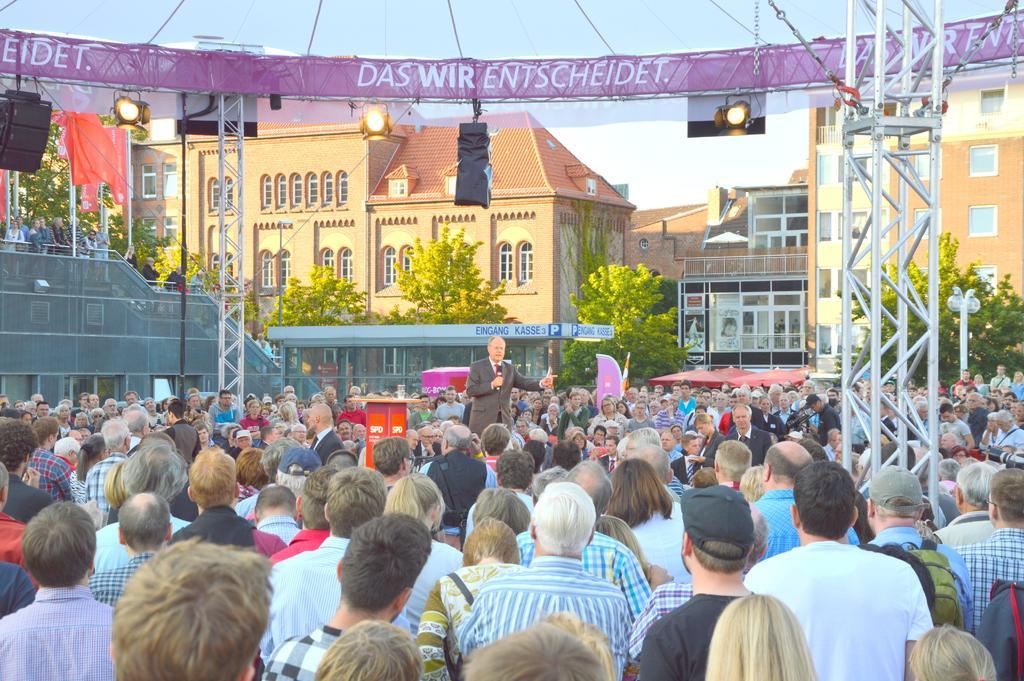In one or two sentences, can you explain what this image depicts? In this image there are many people standing. In the center there is a man standing on the dais. He is holding a microphone. Beside him there is a podium. In the background there are buildings and trees. To the right there is a metal pillar. Behind the pillar there are lights and banners. There is sky in the image. 